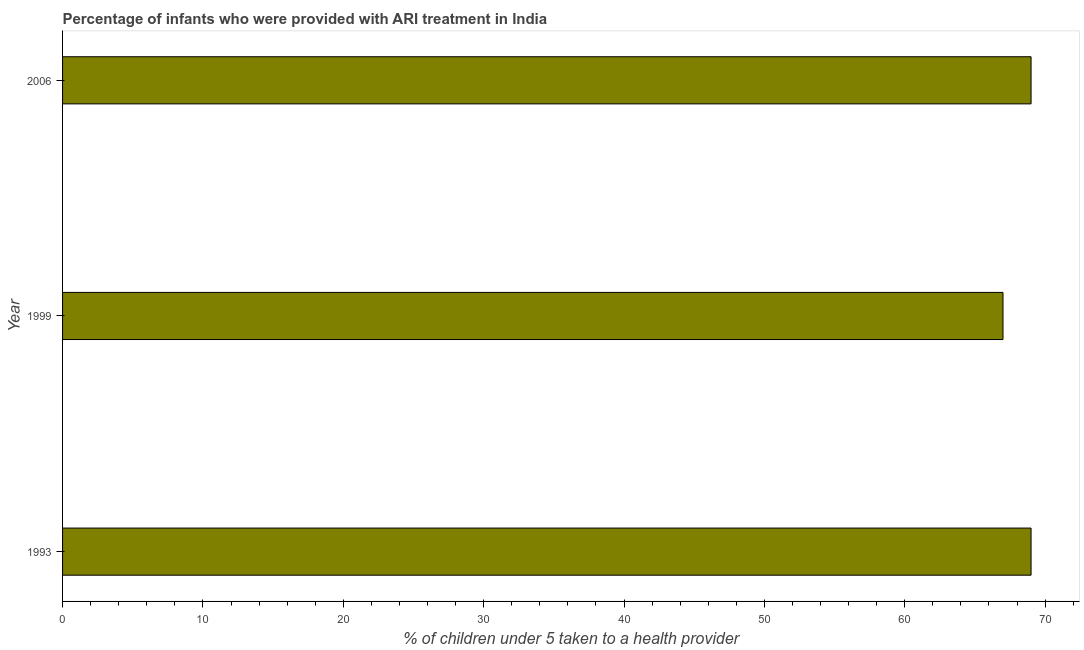Does the graph contain grids?
Keep it short and to the point. No. What is the title of the graph?
Your answer should be very brief. Percentage of infants who were provided with ARI treatment in India. What is the label or title of the X-axis?
Your answer should be compact. % of children under 5 taken to a health provider. What is the label or title of the Y-axis?
Give a very brief answer. Year. What is the percentage of children who were provided with ari treatment in 2006?
Your response must be concise. 69. In which year was the percentage of children who were provided with ari treatment maximum?
Your answer should be compact. 1993. In which year was the percentage of children who were provided with ari treatment minimum?
Provide a succinct answer. 1999. What is the sum of the percentage of children who were provided with ari treatment?
Keep it short and to the point. 205. What is the difference between the percentage of children who were provided with ari treatment in 1993 and 1999?
Give a very brief answer. 2. What is the average percentage of children who were provided with ari treatment per year?
Your answer should be compact. 68. What is the median percentage of children who were provided with ari treatment?
Ensure brevity in your answer.  69. In how many years, is the percentage of children who were provided with ari treatment greater than 40 %?
Make the answer very short. 3. What is the ratio of the percentage of children who were provided with ari treatment in 1993 to that in 1999?
Your answer should be compact. 1.03. Is the percentage of children who were provided with ari treatment in 1999 less than that in 2006?
Ensure brevity in your answer.  Yes. What is the difference between the highest and the second highest percentage of children who were provided with ari treatment?
Your answer should be very brief. 0. In how many years, is the percentage of children who were provided with ari treatment greater than the average percentage of children who were provided with ari treatment taken over all years?
Make the answer very short. 2. Are all the bars in the graph horizontal?
Provide a succinct answer. Yes. Are the values on the major ticks of X-axis written in scientific E-notation?
Your answer should be compact. No. What is the % of children under 5 taken to a health provider in 2006?
Provide a succinct answer. 69. What is the difference between the % of children under 5 taken to a health provider in 1993 and 1999?
Keep it short and to the point. 2. What is the difference between the % of children under 5 taken to a health provider in 1993 and 2006?
Offer a very short reply. 0. What is the difference between the % of children under 5 taken to a health provider in 1999 and 2006?
Give a very brief answer. -2. 